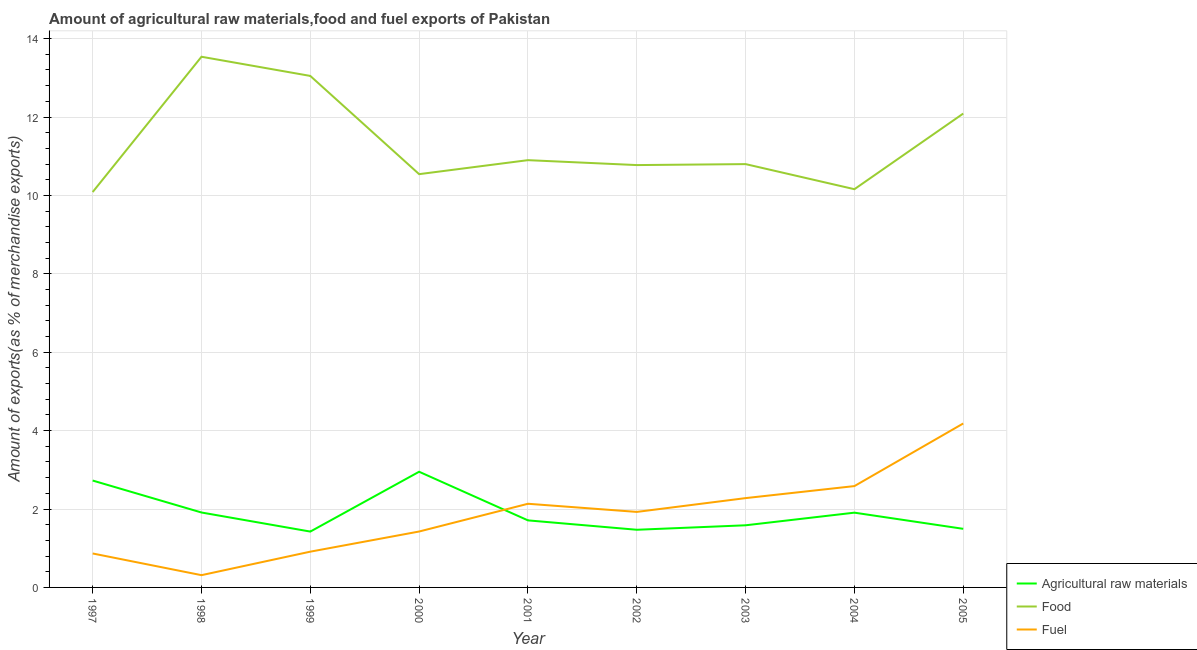Is the number of lines equal to the number of legend labels?
Provide a succinct answer. Yes. What is the percentage of raw materials exports in 2002?
Ensure brevity in your answer.  1.47. Across all years, what is the maximum percentage of fuel exports?
Your answer should be compact. 4.18. Across all years, what is the minimum percentage of food exports?
Offer a terse response. 10.09. In which year was the percentage of food exports maximum?
Your response must be concise. 1998. In which year was the percentage of raw materials exports minimum?
Offer a terse response. 1999. What is the total percentage of fuel exports in the graph?
Your answer should be very brief. 16.62. What is the difference between the percentage of fuel exports in 2004 and that in 2005?
Offer a very short reply. -1.6. What is the difference between the percentage of fuel exports in 1999 and the percentage of food exports in 2003?
Your answer should be compact. -9.89. What is the average percentage of fuel exports per year?
Offer a very short reply. 1.85. In the year 1999, what is the difference between the percentage of fuel exports and percentage of raw materials exports?
Offer a terse response. -0.51. What is the ratio of the percentage of fuel exports in 1997 to that in 2000?
Your answer should be very brief. 0.61. Is the difference between the percentage of food exports in 2002 and 2005 greater than the difference between the percentage of raw materials exports in 2002 and 2005?
Offer a terse response. No. What is the difference between the highest and the second highest percentage of raw materials exports?
Make the answer very short. 0.22. What is the difference between the highest and the lowest percentage of raw materials exports?
Give a very brief answer. 1.53. Is it the case that in every year, the sum of the percentage of raw materials exports and percentage of food exports is greater than the percentage of fuel exports?
Keep it short and to the point. Yes. Is the percentage of fuel exports strictly greater than the percentage of raw materials exports over the years?
Provide a succinct answer. No. How many lines are there?
Make the answer very short. 3. How many years are there in the graph?
Your response must be concise. 9. Where does the legend appear in the graph?
Offer a very short reply. Bottom right. What is the title of the graph?
Your answer should be very brief. Amount of agricultural raw materials,food and fuel exports of Pakistan. What is the label or title of the X-axis?
Keep it short and to the point. Year. What is the label or title of the Y-axis?
Keep it short and to the point. Amount of exports(as % of merchandise exports). What is the Amount of exports(as % of merchandise exports) of Agricultural raw materials in 1997?
Make the answer very short. 2.73. What is the Amount of exports(as % of merchandise exports) in Food in 1997?
Make the answer very short. 10.09. What is the Amount of exports(as % of merchandise exports) in Fuel in 1997?
Provide a short and direct response. 0.87. What is the Amount of exports(as % of merchandise exports) in Agricultural raw materials in 1998?
Offer a terse response. 1.91. What is the Amount of exports(as % of merchandise exports) of Food in 1998?
Offer a very short reply. 13.54. What is the Amount of exports(as % of merchandise exports) in Fuel in 1998?
Ensure brevity in your answer.  0.31. What is the Amount of exports(as % of merchandise exports) in Agricultural raw materials in 1999?
Offer a very short reply. 1.42. What is the Amount of exports(as % of merchandise exports) in Food in 1999?
Ensure brevity in your answer.  13.05. What is the Amount of exports(as % of merchandise exports) of Fuel in 1999?
Ensure brevity in your answer.  0.91. What is the Amount of exports(as % of merchandise exports) in Agricultural raw materials in 2000?
Offer a terse response. 2.95. What is the Amount of exports(as % of merchandise exports) of Food in 2000?
Provide a succinct answer. 10.54. What is the Amount of exports(as % of merchandise exports) of Fuel in 2000?
Offer a very short reply. 1.43. What is the Amount of exports(as % of merchandise exports) of Agricultural raw materials in 2001?
Your response must be concise. 1.71. What is the Amount of exports(as % of merchandise exports) of Food in 2001?
Make the answer very short. 10.9. What is the Amount of exports(as % of merchandise exports) in Fuel in 2001?
Your response must be concise. 2.13. What is the Amount of exports(as % of merchandise exports) in Agricultural raw materials in 2002?
Make the answer very short. 1.47. What is the Amount of exports(as % of merchandise exports) of Food in 2002?
Your answer should be compact. 10.77. What is the Amount of exports(as % of merchandise exports) in Fuel in 2002?
Make the answer very short. 1.93. What is the Amount of exports(as % of merchandise exports) of Agricultural raw materials in 2003?
Keep it short and to the point. 1.59. What is the Amount of exports(as % of merchandise exports) of Food in 2003?
Provide a short and direct response. 10.8. What is the Amount of exports(as % of merchandise exports) in Fuel in 2003?
Your answer should be compact. 2.28. What is the Amount of exports(as % of merchandise exports) of Agricultural raw materials in 2004?
Offer a terse response. 1.91. What is the Amount of exports(as % of merchandise exports) in Food in 2004?
Offer a very short reply. 10.16. What is the Amount of exports(as % of merchandise exports) of Fuel in 2004?
Ensure brevity in your answer.  2.59. What is the Amount of exports(as % of merchandise exports) in Agricultural raw materials in 2005?
Your answer should be compact. 1.49. What is the Amount of exports(as % of merchandise exports) in Food in 2005?
Provide a succinct answer. 12.09. What is the Amount of exports(as % of merchandise exports) in Fuel in 2005?
Offer a very short reply. 4.18. Across all years, what is the maximum Amount of exports(as % of merchandise exports) in Agricultural raw materials?
Your answer should be compact. 2.95. Across all years, what is the maximum Amount of exports(as % of merchandise exports) of Food?
Your answer should be very brief. 13.54. Across all years, what is the maximum Amount of exports(as % of merchandise exports) of Fuel?
Offer a very short reply. 4.18. Across all years, what is the minimum Amount of exports(as % of merchandise exports) of Agricultural raw materials?
Make the answer very short. 1.42. Across all years, what is the minimum Amount of exports(as % of merchandise exports) of Food?
Provide a short and direct response. 10.09. Across all years, what is the minimum Amount of exports(as % of merchandise exports) in Fuel?
Your response must be concise. 0.31. What is the total Amount of exports(as % of merchandise exports) of Agricultural raw materials in the graph?
Your answer should be very brief. 17.18. What is the total Amount of exports(as % of merchandise exports) of Food in the graph?
Give a very brief answer. 101.94. What is the total Amount of exports(as % of merchandise exports) in Fuel in the graph?
Your answer should be compact. 16.62. What is the difference between the Amount of exports(as % of merchandise exports) in Agricultural raw materials in 1997 and that in 1998?
Your response must be concise. 0.82. What is the difference between the Amount of exports(as % of merchandise exports) of Food in 1997 and that in 1998?
Your response must be concise. -3.45. What is the difference between the Amount of exports(as % of merchandise exports) of Fuel in 1997 and that in 1998?
Provide a succinct answer. 0.55. What is the difference between the Amount of exports(as % of merchandise exports) of Agricultural raw materials in 1997 and that in 1999?
Provide a succinct answer. 1.3. What is the difference between the Amount of exports(as % of merchandise exports) in Food in 1997 and that in 1999?
Keep it short and to the point. -2.96. What is the difference between the Amount of exports(as % of merchandise exports) of Fuel in 1997 and that in 1999?
Provide a short and direct response. -0.05. What is the difference between the Amount of exports(as % of merchandise exports) in Agricultural raw materials in 1997 and that in 2000?
Provide a short and direct response. -0.22. What is the difference between the Amount of exports(as % of merchandise exports) in Food in 1997 and that in 2000?
Provide a succinct answer. -0.46. What is the difference between the Amount of exports(as % of merchandise exports) of Fuel in 1997 and that in 2000?
Your answer should be compact. -0.56. What is the difference between the Amount of exports(as % of merchandise exports) of Agricultural raw materials in 1997 and that in 2001?
Provide a succinct answer. 1.02. What is the difference between the Amount of exports(as % of merchandise exports) in Food in 1997 and that in 2001?
Provide a short and direct response. -0.81. What is the difference between the Amount of exports(as % of merchandise exports) in Fuel in 1997 and that in 2001?
Give a very brief answer. -1.27. What is the difference between the Amount of exports(as % of merchandise exports) of Agricultural raw materials in 1997 and that in 2002?
Offer a very short reply. 1.26. What is the difference between the Amount of exports(as % of merchandise exports) in Food in 1997 and that in 2002?
Keep it short and to the point. -0.69. What is the difference between the Amount of exports(as % of merchandise exports) in Fuel in 1997 and that in 2002?
Your answer should be very brief. -1.06. What is the difference between the Amount of exports(as % of merchandise exports) of Agricultural raw materials in 1997 and that in 2003?
Give a very brief answer. 1.14. What is the difference between the Amount of exports(as % of merchandise exports) in Food in 1997 and that in 2003?
Give a very brief answer. -0.71. What is the difference between the Amount of exports(as % of merchandise exports) in Fuel in 1997 and that in 2003?
Offer a very short reply. -1.41. What is the difference between the Amount of exports(as % of merchandise exports) of Agricultural raw materials in 1997 and that in 2004?
Your answer should be compact. 0.82. What is the difference between the Amount of exports(as % of merchandise exports) of Food in 1997 and that in 2004?
Your answer should be very brief. -0.07. What is the difference between the Amount of exports(as % of merchandise exports) of Fuel in 1997 and that in 2004?
Make the answer very short. -1.72. What is the difference between the Amount of exports(as % of merchandise exports) of Agricultural raw materials in 1997 and that in 2005?
Give a very brief answer. 1.23. What is the difference between the Amount of exports(as % of merchandise exports) in Food in 1997 and that in 2005?
Offer a terse response. -2. What is the difference between the Amount of exports(as % of merchandise exports) of Fuel in 1997 and that in 2005?
Your answer should be compact. -3.32. What is the difference between the Amount of exports(as % of merchandise exports) of Agricultural raw materials in 1998 and that in 1999?
Your response must be concise. 0.49. What is the difference between the Amount of exports(as % of merchandise exports) of Food in 1998 and that in 1999?
Offer a terse response. 0.49. What is the difference between the Amount of exports(as % of merchandise exports) in Fuel in 1998 and that in 1999?
Your answer should be very brief. -0.6. What is the difference between the Amount of exports(as % of merchandise exports) of Agricultural raw materials in 1998 and that in 2000?
Your response must be concise. -1.04. What is the difference between the Amount of exports(as % of merchandise exports) of Food in 1998 and that in 2000?
Your response must be concise. 3. What is the difference between the Amount of exports(as % of merchandise exports) in Fuel in 1998 and that in 2000?
Your answer should be very brief. -1.11. What is the difference between the Amount of exports(as % of merchandise exports) of Agricultural raw materials in 1998 and that in 2001?
Offer a terse response. 0.2. What is the difference between the Amount of exports(as % of merchandise exports) in Food in 1998 and that in 2001?
Offer a terse response. 2.64. What is the difference between the Amount of exports(as % of merchandise exports) of Fuel in 1998 and that in 2001?
Ensure brevity in your answer.  -1.82. What is the difference between the Amount of exports(as % of merchandise exports) in Agricultural raw materials in 1998 and that in 2002?
Offer a terse response. 0.44. What is the difference between the Amount of exports(as % of merchandise exports) in Food in 1998 and that in 2002?
Make the answer very short. 2.76. What is the difference between the Amount of exports(as % of merchandise exports) of Fuel in 1998 and that in 2002?
Offer a terse response. -1.61. What is the difference between the Amount of exports(as % of merchandise exports) of Agricultural raw materials in 1998 and that in 2003?
Your answer should be very brief. 0.33. What is the difference between the Amount of exports(as % of merchandise exports) in Food in 1998 and that in 2003?
Give a very brief answer. 2.74. What is the difference between the Amount of exports(as % of merchandise exports) in Fuel in 1998 and that in 2003?
Your answer should be very brief. -1.97. What is the difference between the Amount of exports(as % of merchandise exports) of Agricultural raw materials in 1998 and that in 2004?
Ensure brevity in your answer.  0. What is the difference between the Amount of exports(as % of merchandise exports) in Food in 1998 and that in 2004?
Provide a short and direct response. 3.38. What is the difference between the Amount of exports(as % of merchandise exports) of Fuel in 1998 and that in 2004?
Your answer should be compact. -2.27. What is the difference between the Amount of exports(as % of merchandise exports) of Agricultural raw materials in 1998 and that in 2005?
Offer a very short reply. 0.42. What is the difference between the Amount of exports(as % of merchandise exports) of Food in 1998 and that in 2005?
Offer a terse response. 1.45. What is the difference between the Amount of exports(as % of merchandise exports) in Fuel in 1998 and that in 2005?
Your answer should be compact. -3.87. What is the difference between the Amount of exports(as % of merchandise exports) in Agricultural raw materials in 1999 and that in 2000?
Offer a terse response. -1.53. What is the difference between the Amount of exports(as % of merchandise exports) in Food in 1999 and that in 2000?
Provide a short and direct response. 2.51. What is the difference between the Amount of exports(as % of merchandise exports) in Fuel in 1999 and that in 2000?
Give a very brief answer. -0.51. What is the difference between the Amount of exports(as % of merchandise exports) in Agricultural raw materials in 1999 and that in 2001?
Your response must be concise. -0.29. What is the difference between the Amount of exports(as % of merchandise exports) in Food in 1999 and that in 2001?
Your answer should be compact. 2.15. What is the difference between the Amount of exports(as % of merchandise exports) in Fuel in 1999 and that in 2001?
Your answer should be very brief. -1.22. What is the difference between the Amount of exports(as % of merchandise exports) of Agricultural raw materials in 1999 and that in 2002?
Give a very brief answer. -0.05. What is the difference between the Amount of exports(as % of merchandise exports) of Food in 1999 and that in 2002?
Give a very brief answer. 2.27. What is the difference between the Amount of exports(as % of merchandise exports) in Fuel in 1999 and that in 2002?
Ensure brevity in your answer.  -1.01. What is the difference between the Amount of exports(as % of merchandise exports) in Agricultural raw materials in 1999 and that in 2003?
Your response must be concise. -0.16. What is the difference between the Amount of exports(as % of merchandise exports) in Food in 1999 and that in 2003?
Your answer should be compact. 2.25. What is the difference between the Amount of exports(as % of merchandise exports) in Fuel in 1999 and that in 2003?
Keep it short and to the point. -1.37. What is the difference between the Amount of exports(as % of merchandise exports) in Agricultural raw materials in 1999 and that in 2004?
Give a very brief answer. -0.48. What is the difference between the Amount of exports(as % of merchandise exports) in Food in 1999 and that in 2004?
Provide a succinct answer. 2.89. What is the difference between the Amount of exports(as % of merchandise exports) in Fuel in 1999 and that in 2004?
Ensure brevity in your answer.  -1.67. What is the difference between the Amount of exports(as % of merchandise exports) in Agricultural raw materials in 1999 and that in 2005?
Make the answer very short. -0.07. What is the difference between the Amount of exports(as % of merchandise exports) in Food in 1999 and that in 2005?
Keep it short and to the point. 0.96. What is the difference between the Amount of exports(as % of merchandise exports) in Fuel in 1999 and that in 2005?
Give a very brief answer. -3.27. What is the difference between the Amount of exports(as % of merchandise exports) in Agricultural raw materials in 2000 and that in 2001?
Your answer should be compact. 1.24. What is the difference between the Amount of exports(as % of merchandise exports) of Food in 2000 and that in 2001?
Your answer should be very brief. -0.36. What is the difference between the Amount of exports(as % of merchandise exports) of Fuel in 2000 and that in 2001?
Offer a terse response. -0.71. What is the difference between the Amount of exports(as % of merchandise exports) of Agricultural raw materials in 2000 and that in 2002?
Provide a short and direct response. 1.48. What is the difference between the Amount of exports(as % of merchandise exports) in Food in 2000 and that in 2002?
Your answer should be compact. -0.23. What is the difference between the Amount of exports(as % of merchandise exports) of Fuel in 2000 and that in 2002?
Provide a short and direct response. -0.5. What is the difference between the Amount of exports(as % of merchandise exports) in Agricultural raw materials in 2000 and that in 2003?
Give a very brief answer. 1.37. What is the difference between the Amount of exports(as % of merchandise exports) of Food in 2000 and that in 2003?
Offer a terse response. -0.26. What is the difference between the Amount of exports(as % of merchandise exports) in Fuel in 2000 and that in 2003?
Your answer should be very brief. -0.85. What is the difference between the Amount of exports(as % of merchandise exports) of Agricultural raw materials in 2000 and that in 2004?
Keep it short and to the point. 1.04. What is the difference between the Amount of exports(as % of merchandise exports) of Food in 2000 and that in 2004?
Give a very brief answer. 0.38. What is the difference between the Amount of exports(as % of merchandise exports) of Fuel in 2000 and that in 2004?
Your answer should be compact. -1.16. What is the difference between the Amount of exports(as % of merchandise exports) of Agricultural raw materials in 2000 and that in 2005?
Make the answer very short. 1.46. What is the difference between the Amount of exports(as % of merchandise exports) in Food in 2000 and that in 2005?
Offer a terse response. -1.55. What is the difference between the Amount of exports(as % of merchandise exports) of Fuel in 2000 and that in 2005?
Offer a terse response. -2.76. What is the difference between the Amount of exports(as % of merchandise exports) of Agricultural raw materials in 2001 and that in 2002?
Provide a short and direct response. 0.24. What is the difference between the Amount of exports(as % of merchandise exports) of Food in 2001 and that in 2002?
Keep it short and to the point. 0.13. What is the difference between the Amount of exports(as % of merchandise exports) of Fuel in 2001 and that in 2002?
Make the answer very short. 0.21. What is the difference between the Amount of exports(as % of merchandise exports) of Agricultural raw materials in 2001 and that in 2003?
Your answer should be very brief. 0.13. What is the difference between the Amount of exports(as % of merchandise exports) in Food in 2001 and that in 2003?
Offer a terse response. 0.1. What is the difference between the Amount of exports(as % of merchandise exports) in Fuel in 2001 and that in 2003?
Provide a succinct answer. -0.14. What is the difference between the Amount of exports(as % of merchandise exports) in Agricultural raw materials in 2001 and that in 2004?
Offer a very short reply. -0.2. What is the difference between the Amount of exports(as % of merchandise exports) of Food in 2001 and that in 2004?
Offer a terse response. 0.74. What is the difference between the Amount of exports(as % of merchandise exports) of Fuel in 2001 and that in 2004?
Provide a succinct answer. -0.45. What is the difference between the Amount of exports(as % of merchandise exports) of Agricultural raw materials in 2001 and that in 2005?
Ensure brevity in your answer.  0.22. What is the difference between the Amount of exports(as % of merchandise exports) of Food in 2001 and that in 2005?
Provide a succinct answer. -1.19. What is the difference between the Amount of exports(as % of merchandise exports) in Fuel in 2001 and that in 2005?
Keep it short and to the point. -2.05. What is the difference between the Amount of exports(as % of merchandise exports) of Agricultural raw materials in 2002 and that in 2003?
Your response must be concise. -0.11. What is the difference between the Amount of exports(as % of merchandise exports) in Food in 2002 and that in 2003?
Make the answer very short. -0.02. What is the difference between the Amount of exports(as % of merchandise exports) in Fuel in 2002 and that in 2003?
Your answer should be compact. -0.35. What is the difference between the Amount of exports(as % of merchandise exports) in Agricultural raw materials in 2002 and that in 2004?
Your response must be concise. -0.44. What is the difference between the Amount of exports(as % of merchandise exports) in Food in 2002 and that in 2004?
Give a very brief answer. 0.62. What is the difference between the Amount of exports(as % of merchandise exports) of Fuel in 2002 and that in 2004?
Your answer should be very brief. -0.66. What is the difference between the Amount of exports(as % of merchandise exports) in Agricultural raw materials in 2002 and that in 2005?
Your answer should be compact. -0.02. What is the difference between the Amount of exports(as % of merchandise exports) of Food in 2002 and that in 2005?
Provide a short and direct response. -1.31. What is the difference between the Amount of exports(as % of merchandise exports) in Fuel in 2002 and that in 2005?
Ensure brevity in your answer.  -2.26. What is the difference between the Amount of exports(as % of merchandise exports) in Agricultural raw materials in 2003 and that in 2004?
Keep it short and to the point. -0.32. What is the difference between the Amount of exports(as % of merchandise exports) in Food in 2003 and that in 2004?
Keep it short and to the point. 0.64. What is the difference between the Amount of exports(as % of merchandise exports) of Fuel in 2003 and that in 2004?
Your answer should be very brief. -0.31. What is the difference between the Amount of exports(as % of merchandise exports) in Agricultural raw materials in 2003 and that in 2005?
Ensure brevity in your answer.  0.09. What is the difference between the Amount of exports(as % of merchandise exports) of Food in 2003 and that in 2005?
Provide a short and direct response. -1.29. What is the difference between the Amount of exports(as % of merchandise exports) of Fuel in 2003 and that in 2005?
Ensure brevity in your answer.  -1.9. What is the difference between the Amount of exports(as % of merchandise exports) of Agricultural raw materials in 2004 and that in 2005?
Offer a terse response. 0.41. What is the difference between the Amount of exports(as % of merchandise exports) of Food in 2004 and that in 2005?
Provide a short and direct response. -1.93. What is the difference between the Amount of exports(as % of merchandise exports) in Fuel in 2004 and that in 2005?
Make the answer very short. -1.6. What is the difference between the Amount of exports(as % of merchandise exports) of Agricultural raw materials in 1997 and the Amount of exports(as % of merchandise exports) of Food in 1998?
Offer a very short reply. -10.81. What is the difference between the Amount of exports(as % of merchandise exports) of Agricultural raw materials in 1997 and the Amount of exports(as % of merchandise exports) of Fuel in 1998?
Ensure brevity in your answer.  2.41. What is the difference between the Amount of exports(as % of merchandise exports) of Food in 1997 and the Amount of exports(as % of merchandise exports) of Fuel in 1998?
Make the answer very short. 9.77. What is the difference between the Amount of exports(as % of merchandise exports) of Agricultural raw materials in 1997 and the Amount of exports(as % of merchandise exports) of Food in 1999?
Keep it short and to the point. -10.32. What is the difference between the Amount of exports(as % of merchandise exports) of Agricultural raw materials in 1997 and the Amount of exports(as % of merchandise exports) of Fuel in 1999?
Make the answer very short. 1.81. What is the difference between the Amount of exports(as % of merchandise exports) of Food in 1997 and the Amount of exports(as % of merchandise exports) of Fuel in 1999?
Make the answer very short. 9.17. What is the difference between the Amount of exports(as % of merchandise exports) in Agricultural raw materials in 1997 and the Amount of exports(as % of merchandise exports) in Food in 2000?
Provide a succinct answer. -7.82. What is the difference between the Amount of exports(as % of merchandise exports) in Agricultural raw materials in 1997 and the Amount of exports(as % of merchandise exports) in Fuel in 2000?
Give a very brief answer. 1.3. What is the difference between the Amount of exports(as % of merchandise exports) of Food in 1997 and the Amount of exports(as % of merchandise exports) of Fuel in 2000?
Offer a very short reply. 8.66. What is the difference between the Amount of exports(as % of merchandise exports) in Agricultural raw materials in 1997 and the Amount of exports(as % of merchandise exports) in Food in 2001?
Give a very brief answer. -8.17. What is the difference between the Amount of exports(as % of merchandise exports) of Agricultural raw materials in 1997 and the Amount of exports(as % of merchandise exports) of Fuel in 2001?
Keep it short and to the point. 0.59. What is the difference between the Amount of exports(as % of merchandise exports) of Food in 1997 and the Amount of exports(as % of merchandise exports) of Fuel in 2001?
Provide a short and direct response. 7.95. What is the difference between the Amount of exports(as % of merchandise exports) of Agricultural raw materials in 1997 and the Amount of exports(as % of merchandise exports) of Food in 2002?
Offer a very short reply. -8.05. What is the difference between the Amount of exports(as % of merchandise exports) of Agricultural raw materials in 1997 and the Amount of exports(as % of merchandise exports) of Fuel in 2002?
Ensure brevity in your answer.  0.8. What is the difference between the Amount of exports(as % of merchandise exports) in Food in 1997 and the Amount of exports(as % of merchandise exports) in Fuel in 2002?
Offer a terse response. 8.16. What is the difference between the Amount of exports(as % of merchandise exports) in Agricultural raw materials in 1997 and the Amount of exports(as % of merchandise exports) in Food in 2003?
Your response must be concise. -8.07. What is the difference between the Amount of exports(as % of merchandise exports) in Agricultural raw materials in 1997 and the Amount of exports(as % of merchandise exports) in Fuel in 2003?
Your response must be concise. 0.45. What is the difference between the Amount of exports(as % of merchandise exports) of Food in 1997 and the Amount of exports(as % of merchandise exports) of Fuel in 2003?
Keep it short and to the point. 7.81. What is the difference between the Amount of exports(as % of merchandise exports) of Agricultural raw materials in 1997 and the Amount of exports(as % of merchandise exports) of Food in 2004?
Offer a very short reply. -7.43. What is the difference between the Amount of exports(as % of merchandise exports) in Agricultural raw materials in 1997 and the Amount of exports(as % of merchandise exports) in Fuel in 2004?
Provide a short and direct response. 0.14. What is the difference between the Amount of exports(as % of merchandise exports) of Food in 1997 and the Amount of exports(as % of merchandise exports) of Fuel in 2004?
Your answer should be very brief. 7.5. What is the difference between the Amount of exports(as % of merchandise exports) in Agricultural raw materials in 1997 and the Amount of exports(as % of merchandise exports) in Food in 2005?
Offer a terse response. -9.36. What is the difference between the Amount of exports(as % of merchandise exports) of Agricultural raw materials in 1997 and the Amount of exports(as % of merchandise exports) of Fuel in 2005?
Provide a short and direct response. -1.46. What is the difference between the Amount of exports(as % of merchandise exports) in Food in 1997 and the Amount of exports(as % of merchandise exports) in Fuel in 2005?
Keep it short and to the point. 5.9. What is the difference between the Amount of exports(as % of merchandise exports) in Agricultural raw materials in 1998 and the Amount of exports(as % of merchandise exports) in Food in 1999?
Your response must be concise. -11.14. What is the difference between the Amount of exports(as % of merchandise exports) of Agricultural raw materials in 1998 and the Amount of exports(as % of merchandise exports) of Fuel in 1999?
Provide a short and direct response. 1. What is the difference between the Amount of exports(as % of merchandise exports) of Food in 1998 and the Amount of exports(as % of merchandise exports) of Fuel in 1999?
Keep it short and to the point. 12.63. What is the difference between the Amount of exports(as % of merchandise exports) in Agricultural raw materials in 1998 and the Amount of exports(as % of merchandise exports) in Food in 2000?
Your answer should be very brief. -8.63. What is the difference between the Amount of exports(as % of merchandise exports) in Agricultural raw materials in 1998 and the Amount of exports(as % of merchandise exports) in Fuel in 2000?
Keep it short and to the point. 0.49. What is the difference between the Amount of exports(as % of merchandise exports) of Food in 1998 and the Amount of exports(as % of merchandise exports) of Fuel in 2000?
Keep it short and to the point. 12.11. What is the difference between the Amount of exports(as % of merchandise exports) of Agricultural raw materials in 1998 and the Amount of exports(as % of merchandise exports) of Food in 2001?
Offer a terse response. -8.99. What is the difference between the Amount of exports(as % of merchandise exports) in Agricultural raw materials in 1998 and the Amount of exports(as % of merchandise exports) in Fuel in 2001?
Offer a very short reply. -0.22. What is the difference between the Amount of exports(as % of merchandise exports) in Food in 1998 and the Amount of exports(as % of merchandise exports) in Fuel in 2001?
Give a very brief answer. 11.4. What is the difference between the Amount of exports(as % of merchandise exports) of Agricultural raw materials in 1998 and the Amount of exports(as % of merchandise exports) of Food in 2002?
Your response must be concise. -8.86. What is the difference between the Amount of exports(as % of merchandise exports) in Agricultural raw materials in 1998 and the Amount of exports(as % of merchandise exports) in Fuel in 2002?
Your answer should be very brief. -0.01. What is the difference between the Amount of exports(as % of merchandise exports) in Food in 1998 and the Amount of exports(as % of merchandise exports) in Fuel in 2002?
Provide a succinct answer. 11.61. What is the difference between the Amount of exports(as % of merchandise exports) in Agricultural raw materials in 1998 and the Amount of exports(as % of merchandise exports) in Food in 2003?
Your response must be concise. -8.89. What is the difference between the Amount of exports(as % of merchandise exports) in Agricultural raw materials in 1998 and the Amount of exports(as % of merchandise exports) in Fuel in 2003?
Offer a very short reply. -0.37. What is the difference between the Amount of exports(as % of merchandise exports) in Food in 1998 and the Amount of exports(as % of merchandise exports) in Fuel in 2003?
Give a very brief answer. 11.26. What is the difference between the Amount of exports(as % of merchandise exports) in Agricultural raw materials in 1998 and the Amount of exports(as % of merchandise exports) in Food in 2004?
Make the answer very short. -8.25. What is the difference between the Amount of exports(as % of merchandise exports) in Agricultural raw materials in 1998 and the Amount of exports(as % of merchandise exports) in Fuel in 2004?
Offer a terse response. -0.67. What is the difference between the Amount of exports(as % of merchandise exports) in Food in 1998 and the Amount of exports(as % of merchandise exports) in Fuel in 2004?
Provide a short and direct response. 10.95. What is the difference between the Amount of exports(as % of merchandise exports) of Agricultural raw materials in 1998 and the Amount of exports(as % of merchandise exports) of Food in 2005?
Ensure brevity in your answer.  -10.18. What is the difference between the Amount of exports(as % of merchandise exports) of Agricultural raw materials in 1998 and the Amount of exports(as % of merchandise exports) of Fuel in 2005?
Your answer should be compact. -2.27. What is the difference between the Amount of exports(as % of merchandise exports) in Food in 1998 and the Amount of exports(as % of merchandise exports) in Fuel in 2005?
Give a very brief answer. 9.36. What is the difference between the Amount of exports(as % of merchandise exports) of Agricultural raw materials in 1999 and the Amount of exports(as % of merchandise exports) of Food in 2000?
Offer a terse response. -9.12. What is the difference between the Amount of exports(as % of merchandise exports) in Agricultural raw materials in 1999 and the Amount of exports(as % of merchandise exports) in Fuel in 2000?
Your answer should be very brief. -0. What is the difference between the Amount of exports(as % of merchandise exports) in Food in 1999 and the Amount of exports(as % of merchandise exports) in Fuel in 2000?
Your answer should be very brief. 11.62. What is the difference between the Amount of exports(as % of merchandise exports) of Agricultural raw materials in 1999 and the Amount of exports(as % of merchandise exports) of Food in 2001?
Your response must be concise. -9.48. What is the difference between the Amount of exports(as % of merchandise exports) in Agricultural raw materials in 1999 and the Amount of exports(as % of merchandise exports) in Fuel in 2001?
Ensure brevity in your answer.  -0.71. What is the difference between the Amount of exports(as % of merchandise exports) of Food in 1999 and the Amount of exports(as % of merchandise exports) of Fuel in 2001?
Provide a succinct answer. 10.91. What is the difference between the Amount of exports(as % of merchandise exports) in Agricultural raw materials in 1999 and the Amount of exports(as % of merchandise exports) in Food in 2002?
Your answer should be compact. -9.35. What is the difference between the Amount of exports(as % of merchandise exports) in Agricultural raw materials in 1999 and the Amount of exports(as % of merchandise exports) in Fuel in 2002?
Offer a terse response. -0.5. What is the difference between the Amount of exports(as % of merchandise exports) in Food in 1999 and the Amount of exports(as % of merchandise exports) in Fuel in 2002?
Keep it short and to the point. 11.12. What is the difference between the Amount of exports(as % of merchandise exports) in Agricultural raw materials in 1999 and the Amount of exports(as % of merchandise exports) in Food in 2003?
Provide a succinct answer. -9.37. What is the difference between the Amount of exports(as % of merchandise exports) in Agricultural raw materials in 1999 and the Amount of exports(as % of merchandise exports) in Fuel in 2003?
Keep it short and to the point. -0.85. What is the difference between the Amount of exports(as % of merchandise exports) of Food in 1999 and the Amount of exports(as % of merchandise exports) of Fuel in 2003?
Make the answer very short. 10.77. What is the difference between the Amount of exports(as % of merchandise exports) in Agricultural raw materials in 1999 and the Amount of exports(as % of merchandise exports) in Food in 2004?
Your answer should be very brief. -8.73. What is the difference between the Amount of exports(as % of merchandise exports) in Agricultural raw materials in 1999 and the Amount of exports(as % of merchandise exports) in Fuel in 2004?
Make the answer very short. -1.16. What is the difference between the Amount of exports(as % of merchandise exports) in Food in 1999 and the Amount of exports(as % of merchandise exports) in Fuel in 2004?
Provide a short and direct response. 10.46. What is the difference between the Amount of exports(as % of merchandise exports) of Agricultural raw materials in 1999 and the Amount of exports(as % of merchandise exports) of Food in 2005?
Ensure brevity in your answer.  -10.66. What is the difference between the Amount of exports(as % of merchandise exports) of Agricultural raw materials in 1999 and the Amount of exports(as % of merchandise exports) of Fuel in 2005?
Ensure brevity in your answer.  -2.76. What is the difference between the Amount of exports(as % of merchandise exports) in Food in 1999 and the Amount of exports(as % of merchandise exports) in Fuel in 2005?
Your answer should be compact. 8.87. What is the difference between the Amount of exports(as % of merchandise exports) of Agricultural raw materials in 2000 and the Amount of exports(as % of merchandise exports) of Food in 2001?
Provide a succinct answer. -7.95. What is the difference between the Amount of exports(as % of merchandise exports) in Agricultural raw materials in 2000 and the Amount of exports(as % of merchandise exports) in Fuel in 2001?
Keep it short and to the point. 0.82. What is the difference between the Amount of exports(as % of merchandise exports) in Food in 2000 and the Amount of exports(as % of merchandise exports) in Fuel in 2001?
Keep it short and to the point. 8.41. What is the difference between the Amount of exports(as % of merchandise exports) of Agricultural raw materials in 2000 and the Amount of exports(as % of merchandise exports) of Food in 2002?
Keep it short and to the point. -7.82. What is the difference between the Amount of exports(as % of merchandise exports) in Agricultural raw materials in 2000 and the Amount of exports(as % of merchandise exports) in Fuel in 2002?
Keep it short and to the point. 1.02. What is the difference between the Amount of exports(as % of merchandise exports) of Food in 2000 and the Amount of exports(as % of merchandise exports) of Fuel in 2002?
Offer a terse response. 8.62. What is the difference between the Amount of exports(as % of merchandise exports) of Agricultural raw materials in 2000 and the Amount of exports(as % of merchandise exports) of Food in 2003?
Your answer should be compact. -7.85. What is the difference between the Amount of exports(as % of merchandise exports) of Agricultural raw materials in 2000 and the Amount of exports(as % of merchandise exports) of Fuel in 2003?
Provide a succinct answer. 0.67. What is the difference between the Amount of exports(as % of merchandise exports) in Food in 2000 and the Amount of exports(as % of merchandise exports) in Fuel in 2003?
Your answer should be very brief. 8.26. What is the difference between the Amount of exports(as % of merchandise exports) of Agricultural raw materials in 2000 and the Amount of exports(as % of merchandise exports) of Food in 2004?
Provide a short and direct response. -7.21. What is the difference between the Amount of exports(as % of merchandise exports) of Agricultural raw materials in 2000 and the Amount of exports(as % of merchandise exports) of Fuel in 2004?
Give a very brief answer. 0.37. What is the difference between the Amount of exports(as % of merchandise exports) in Food in 2000 and the Amount of exports(as % of merchandise exports) in Fuel in 2004?
Offer a very short reply. 7.96. What is the difference between the Amount of exports(as % of merchandise exports) of Agricultural raw materials in 2000 and the Amount of exports(as % of merchandise exports) of Food in 2005?
Give a very brief answer. -9.14. What is the difference between the Amount of exports(as % of merchandise exports) of Agricultural raw materials in 2000 and the Amount of exports(as % of merchandise exports) of Fuel in 2005?
Your answer should be very brief. -1.23. What is the difference between the Amount of exports(as % of merchandise exports) in Food in 2000 and the Amount of exports(as % of merchandise exports) in Fuel in 2005?
Your answer should be compact. 6.36. What is the difference between the Amount of exports(as % of merchandise exports) in Agricultural raw materials in 2001 and the Amount of exports(as % of merchandise exports) in Food in 2002?
Offer a terse response. -9.06. What is the difference between the Amount of exports(as % of merchandise exports) of Agricultural raw materials in 2001 and the Amount of exports(as % of merchandise exports) of Fuel in 2002?
Provide a short and direct response. -0.22. What is the difference between the Amount of exports(as % of merchandise exports) of Food in 2001 and the Amount of exports(as % of merchandise exports) of Fuel in 2002?
Give a very brief answer. 8.97. What is the difference between the Amount of exports(as % of merchandise exports) in Agricultural raw materials in 2001 and the Amount of exports(as % of merchandise exports) in Food in 2003?
Your answer should be compact. -9.09. What is the difference between the Amount of exports(as % of merchandise exports) in Agricultural raw materials in 2001 and the Amount of exports(as % of merchandise exports) in Fuel in 2003?
Ensure brevity in your answer.  -0.57. What is the difference between the Amount of exports(as % of merchandise exports) of Food in 2001 and the Amount of exports(as % of merchandise exports) of Fuel in 2003?
Give a very brief answer. 8.62. What is the difference between the Amount of exports(as % of merchandise exports) of Agricultural raw materials in 2001 and the Amount of exports(as % of merchandise exports) of Food in 2004?
Provide a short and direct response. -8.45. What is the difference between the Amount of exports(as % of merchandise exports) in Agricultural raw materials in 2001 and the Amount of exports(as % of merchandise exports) in Fuel in 2004?
Keep it short and to the point. -0.87. What is the difference between the Amount of exports(as % of merchandise exports) of Food in 2001 and the Amount of exports(as % of merchandise exports) of Fuel in 2004?
Provide a succinct answer. 8.31. What is the difference between the Amount of exports(as % of merchandise exports) in Agricultural raw materials in 2001 and the Amount of exports(as % of merchandise exports) in Food in 2005?
Your answer should be compact. -10.38. What is the difference between the Amount of exports(as % of merchandise exports) of Agricultural raw materials in 2001 and the Amount of exports(as % of merchandise exports) of Fuel in 2005?
Offer a very short reply. -2.47. What is the difference between the Amount of exports(as % of merchandise exports) in Food in 2001 and the Amount of exports(as % of merchandise exports) in Fuel in 2005?
Make the answer very short. 6.72. What is the difference between the Amount of exports(as % of merchandise exports) of Agricultural raw materials in 2002 and the Amount of exports(as % of merchandise exports) of Food in 2003?
Provide a short and direct response. -9.33. What is the difference between the Amount of exports(as % of merchandise exports) in Agricultural raw materials in 2002 and the Amount of exports(as % of merchandise exports) in Fuel in 2003?
Make the answer very short. -0.81. What is the difference between the Amount of exports(as % of merchandise exports) in Food in 2002 and the Amount of exports(as % of merchandise exports) in Fuel in 2003?
Your answer should be compact. 8.5. What is the difference between the Amount of exports(as % of merchandise exports) in Agricultural raw materials in 2002 and the Amount of exports(as % of merchandise exports) in Food in 2004?
Offer a terse response. -8.69. What is the difference between the Amount of exports(as % of merchandise exports) in Agricultural raw materials in 2002 and the Amount of exports(as % of merchandise exports) in Fuel in 2004?
Give a very brief answer. -1.11. What is the difference between the Amount of exports(as % of merchandise exports) in Food in 2002 and the Amount of exports(as % of merchandise exports) in Fuel in 2004?
Offer a very short reply. 8.19. What is the difference between the Amount of exports(as % of merchandise exports) of Agricultural raw materials in 2002 and the Amount of exports(as % of merchandise exports) of Food in 2005?
Provide a succinct answer. -10.62. What is the difference between the Amount of exports(as % of merchandise exports) of Agricultural raw materials in 2002 and the Amount of exports(as % of merchandise exports) of Fuel in 2005?
Give a very brief answer. -2.71. What is the difference between the Amount of exports(as % of merchandise exports) in Food in 2002 and the Amount of exports(as % of merchandise exports) in Fuel in 2005?
Offer a very short reply. 6.59. What is the difference between the Amount of exports(as % of merchandise exports) in Agricultural raw materials in 2003 and the Amount of exports(as % of merchandise exports) in Food in 2004?
Your response must be concise. -8.57. What is the difference between the Amount of exports(as % of merchandise exports) in Agricultural raw materials in 2003 and the Amount of exports(as % of merchandise exports) in Fuel in 2004?
Your answer should be compact. -1. What is the difference between the Amount of exports(as % of merchandise exports) of Food in 2003 and the Amount of exports(as % of merchandise exports) of Fuel in 2004?
Make the answer very short. 8.21. What is the difference between the Amount of exports(as % of merchandise exports) of Agricultural raw materials in 2003 and the Amount of exports(as % of merchandise exports) of Food in 2005?
Give a very brief answer. -10.5. What is the difference between the Amount of exports(as % of merchandise exports) in Agricultural raw materials in 2003 and the Amount of exports(as % of merchandise exports) in Fuel in 2005?
Your response must be concise. -2.6. What is the difference between the Amount of exports(as % of merchandise exports) of Food in 2003 and the Amount of exports(as % of merchandise exports) of Fuel in 2005?
Your answer should be very brief. 6.62. What is the difference between the Amount of exports(as % of merchandise exports) in Agricultural raw materials in 2004 and the Amount of exports(as % of merchandise exports) in Food in 2005?
Make the answer very short. -10.18. What is the difference between the Amount of exports(as % of merchandise exports) in Agricultural raw materials in 2004 and the Amount of exports(as % of merchandise exports) in Fuel in 2005?
Ensure brevity in your answer.  -2.27. What is the difference between the Amount of exports(as % of merchandise exports) of Food in 2004 and the Amount of exports(as % of merchandise exports) of Fuel in 2005?
Make the answer very short. 5.98. What is the average Amount of exports(as % of merchandise exports) of Agricultural raw materials per year?
Your answer should be very brief. 1.91. What is the average Amount of exports(as % of merchandise exports) in Food per year?
Offer a very short reply. 11.33. What is the average Amount of exports(as % of merchandise exports) of Fuel per year?
Provide a succinct answer. 1.85. In the year 1997, what is the difference between the Amount of exports(as % of merchandise exports) of Agricultural raw materials and Amount of exports(as % of merchandise exports) of Food?
Give a very brief answer. -7.36. In the year 1997, what is the difference between the Amount of exports(as % of merchandise exports) in Agricultural raw materials and Amount of exports(as % of merchandise exports) in Fuel?
Make the answer very short. 1.86. In the year 1997, what is the difference between the Amount of exports(as % of merchandise exports) in Food and Amount of exports(as % of merchandise exports) in Fuel?
Your answer should be very brief. 9.22. In the year 1998, what is the difference between the Amount of exports(as % of merchandise exports) of Agricultural raw materials and Amount of exports(as % of merchandise exports) of Food?
Offer a very short reply. -11.63. In the year 1998, what is the difference between the Amount of exports(as % of merchandise exports) of Agricultural raw materials and Amount of exports(as % of merchandise exports) of Fuel?
Keep it short and to the point. 1.6. In the year 1998, what is the difference between the Amount of exports(as % of merchandise exports) in Food and Amount of exports(as % of merchandise exports) in Fuel?
Make the answer very short. 13.22. In the year 1999, what is the difference between the Amount of exports(as % of merchandise exports) in Agricultural raw materials and Amount of exports(as % of merchandise exports) in Food?
Your answer should be very brief. -11.62. In the year 1999, what is the difference between the Amount of exports(as % of merchandise exports) of Agricultural raw materials and Amount of exports(as % of merchandise exports) of Fuel?
Give a very brief answer. 0.51. In the year 1999, what is the difference between the Amount of exports(as % of merchandise exports) of Food and Amount of exports(as % of merchandise exports) of Fuel?
Your answer should be compact. 12.14. In the year 2000, what is the difference between the Amount of exports(as % of merchandise exports) of Agricultural raw materials and Amount of exports(as % of merchandise exports) of Food?
Make the answer very short. -7.59. In the year 2000, what is the difference between the Amount of exports(as % of merchandise exports) in Agricultural raw materials and Amount of exports(as % of merchandise exports) in Fuel?
Your response must be concise. 1.52. In the year 2000, what is the difference between the Amount of exports(as % of merchandise exports) in Food and Amount of exports(as % of merchandise exports) in Fuel?
Offer a terse response. 9.12. In the year 2001, what is the difference between the Amount of exports(as % of merchandise exports) in Agricultural raw materials and Amount of exports(as % of merchandise exports) in Food?
Provide a succinct answer. -9.19. In the year 2001, what is the difference between the Amount of exports(as % of merchandise exports) of Agricultural raw materials and Amount of exports(as % of merchandise exports) of Fuel?
Provide a succinct answer. -0.42. In the year 2001, what is the difference between the Amount of exports(as % of merchandise exports) of Food and Amount of exports(as % of merchandise exports) of Fuel?
Keep it short and to the point. 8.77. In the year 2002, what is the difference between the Amount of exports(as % of merchandise exports) in Agricultural raw materials and Amount of exports(as % of merchandise exports) in Food?
Offer a very short reply. -9.3. In the year 2002, what is the difference between the Amount of exports(as % of merchandise exports) in Agricultural raw materials and Amount of exports(as % of merchandise exports) in Fuel?
Offer a very short reply. -0.46. In the year 2002, what is the difference between the Amount of exports(as % of merchandise exports) in Food and Amount of exports(as % of merchandise exports) in Fuel?
Provide a succinct answer. 8.85. In the year 2003, what is the difference between the Amount of exports(as % of merchandise exports) of Agricultural raw materials and Amount of exports(as % of merchandise exports) of Food?
Ensure brevity in your answer.  -9.21. In the year 2003, what is the difference between the Amount of exports(as % of merchandise exports) of Agricultural raw materials and Amount of exports(as % of merchandise exports) of Fuel?
Your answer should be very brief. -0.69. In the year 2003, what is the difference between the Amount of exports(as % of merchandise exports) in Food and Amount of exports(as % of merchandise exports) in Fuel?
Provide a short and direct response. 8.52. In the year 2004, what is the difference between the Amount of exports(as % of merchandise exports) of Agricultural raw materials and Amount of exports(as % of merchandise exports) of Food?
Provide a short and direct response. -8.25. In the year 2004, what is the difference between the Amount of exports(as % of merchandise exports) of Agricultural raw materials and Amount of exports(as % of merchandise exports) of Fuel?
Ensure brevity in your answer.  -0.68. In the year 2004, what is the difference between the Amount of exports(as % of merchandise exports) of Food and Amount of exports(as % of merchandise exports) of Fuel?
Your answer should be compact. 7.57. In the year 2005, what is the difference between the Amount of exports(as % of merchandise exports) of Agricultural raw materials and Amount of exports(as % of merchandise exports) of Food?
Make the answer very short. -10.59. In the year 2005, what is the difference between the Amount of exports(as % of merchandise exports) of Agricultural raw materials and Amount of exports(as % of merchandise exports) of Fuel?
Your response must be concise. -2.69. In the year 2005, what is the difference between the Amount of exports(as % of merchandise exports) of Food and Amount of exports(as % of merchandise exports) of Fuel?
Keep it short and to the point. 7.91. What is the ratio of the Amount of exports(as % of merchandise exports) of Agricultural raw materials in 1997 to that in 1998?
Your answer should be very brief. 1.43. What is the ratio of the Amount of exports(as % of merchandise exports) of Food in 1997 to that in 1998?
Your answer should be very brief. 0.74. What is the ratio of the Amount of exports(as % of merchandise exports) in Fuel in 1997 to that in 1998?
Ensure brevity in your answer.  2.77. What is the ratio of the Amount of exports(as % of merchandise exports) in Agricultural raw materials in 1997 to that in 1999?
Provide a succinct answer. 1.91. What is the ratio of the Amount of exports(as % of merchandise exports) of Food in 1997 to that in 1999?
Keep it short and to the point. 0.77. What is the ratio of the Amount of exports(as % of merchandise exports) of Fuel in 1997 to that in 1999?
Give a very brief answer. 0.95. What is the ratio of the Amount of exports(as % of merchandise exports) of Agricultural raw materials in 1997 to that in 2000?
Keep it short and to the point. 0.92. What is the ratio of the Amount of exports(as % of merchandise exports) of Food in 1997 to that in 2000?
Give a very brief answer. 0.96. What is the ratio of the Amount of exports(as % of merchandise exports) of Fuel in 1997 to that in 2000?
Offer a very short reply. 0.61. What is the ratio of the Amount of exports(as % of merchandise exports) in Agricultural raw materials in 1997 to that in 2001?
Your response must be concise. 1.59. What is the ratio of the Amount of exports(as % of merchandise exports) of Food in 1997 to that in 2001?
Offer a very short reply. 0.93. What is the ratio of the Amount of exports(as % of merchandise exports) in Fuel in 1997 to that in 2001?
Offer a terse response. 0.41. What is the ratio of the Amount of exports(as % of merchandise exports) in Agricultural raw materials in 1997 to that in 2002?
Ensure brevity in your answer.  1.85. What is the ratio of the Amount of exports(as % of merchandise exports) in Food in 1997 to that in 2002?
Offer a very short reply. 0.94. What is the ratio of the Amount of exports(as % of merchandise exports) in Fuel in 1997 to that in 2002?
Your response must be concise. 0.45. What is the ratio of the Amount of exports(as % of merchandise exports) in Agricultural raw materials in 1997 to that in 2003?
Your answer should be compact. 1.72. What is the ratio of the Amount of exports(as % of merchandise exports) of Food in 1997 to that in 2003?
Make the answer very short. 0.93. What is the ratio of the Amount of exports(as % of merchandise exports) of Fuel in 1997 to that in 2003?
Ensure brevity in your answer.  0.38. What is the ratio of the Amount of exports(as % of merchandise exports) in Agricultural raw materials in 1997 to that in 2004?
Provide a short and direct response. 1.43. What is the ratio of the Amount of exports(as % of merchandise exports) in Fuel in 1997 to that in 2004?
Your answer should be compact. 0.34. What is the ratio of the Amount of exports(as % of merchandise exports) of Agricultural raw materials in 1997 to that in 2005?
Provide a succinct answer. 1.82. What is the ratio of the Amount of exports(as % of merchandise exports) in Food in 1997 to that in 2005?
Your response must be concise. 0.83. What is the ratio of the Amount of exports(as % of merchandise exports) in Fuel in 1997 to that in 2005?
Your answer should be compact. 0.21. What is the ratio of the Amount of exports(as % of merchandise exports) in Agricultural raw materials in 1998 to that in 1999?
Provide a short and direct response. 1.34. What is the ratio of the Amount of exports(as % of merchandise exports) of Food in 1998 to that in 1999?
Give a very brief answer. 1.04. What is the ratio of the Amount of exports(as % of merchandise exports) in Fuel in 1998 to that in 1999?
Your answer should be compact. 0.34. What is the ratio of the Amount of exports(as % of merchandise exports) of Agricultural raw materials in 1998 to that in 2000?
Keep it short and to the point. 0.65. What is the ratio of the Amount of exports(as % of merchandise exports) of Food in 1998 to that in 2000?
Your answer should be compact. 1.28. What is the ratio of the Amount of exports(as % of merchandise exports) of Fuel in 1998 to that in 2000?
Make the answer very short. 0.22. What is the ratio of the Amount of exports(as % of merchandise exports) in Agricultural raw materials in 1998 to that in 2001?
Give a very brief answer. 1.12. What is the ratio of the Amount of exports(as % of merchandise exports) of Food in 1998 to that in 2001?
Provide a succinct answer. 1.24. What is the ratio of the Amount of exports(as % of merchandise exports) in Fuel in 1998 to that in 2001?
Your answer should be compact. 0.15. What is the ratio of the Amount of exports(as % of merchandise exports) in Agricultural raw materials in 1998 to that in 2002?
Keep it short and to the point. 1.3. What is the ratio of the Amount of exports(as % of merchandise exports) of Food in 1998 to that in 2002?
Offer a very short reply. 1.26. What is the ratio of the Amount of exports(as % of merchandise exports) of Fuel in 1998 to that in 2002?
Keep it short and to the point. 0.16. What is the ratio of the Amount of exports(as % of merchandise exports) of Agricultural raw materials in 1998 to that in 2003?
Make the answer very short. 1.21. What is the ratio of the Amount of exports(as % of merchandise exports) of Food in 1998 to that in 2003?
Your answer should be compact. 1.25. What is the ratio of the Amount of exports(as % of merchandise exports) of Fuel in 1998 to that in 2003?
Keep it short and to the point. 0.14. What is the ratio of the Amount of exports(as % of merchandise exports) of Food in 1998 to that in 2004?
Provide a succinct answer. 1.33. What is the ratio of the Amount of exports(as % of merchandise exports) of Fuel in 1998 to that in 2004?
Make the answer very short. 0.12. What is the ratio of the Amount of exports(as % of merchandise exports) in Agricultural raw materials in 1998 to that in 2005?
Keep it short and to the point. 1.28. What is the ratio of the Amount of exports(as % of merchandise exports) of Food in 1998 to that in 2005?
Provide a short and direct response. 1.12. What is the ratio of the Amount of exports(as % of merchandise exports) of Fuel in 1998 to that in 2005?
Ensure brevity in your answer.  0.07. What is the ratio of the Amount of exports(as % of merchandise exports) of Agricultural raw materials in 1999 to that in 2000?
Ensure brevity in your answer.  0.48. What is the ratio of the Amount of exports(as % of merchandise exports) of Food in 1999 to that in 2000?
Provide a short and direct response. 1.24. What is the ratio of the Amount of exports(as % of merchandise exports) in Fuel in 1999 to that in 2000?
Provide a succinct answer. 0.64. What is the ratio of the Amount of exports(as % of merchandise exports) in Agricultural raw materials in 1999 to that in 2001?
Ensure brevity in your answer.  0.83. What is the ratio of the Amount of exports(as % of merchandise exports) of Food in 1999 to that in 2001?
Offer a terse response. 1.2. What is the ratio of the Amount of exports(as % of merchandise exports) in Fuel in 1999 to that in 2001?
Your response must be concise. 0.43. What is the ratio of the Amount of exports(as % of merchandise exports) of Agricultural raw materials in 1999 to that in 2002?
Ensure brevity in your answer.  0.97. What is the ratio of the Amount of exports(as % of merchandise exports) in Food in 1999 to that in 2002?
Make the answer very short. 1.21. What is the ratio of the Amount of exports(as % of merchandise exports) in Fuel in 1999 to that in 2002?
Offer a terse response. 0.47. What is the ratio of the Amount of exports(as % of merchandise exports) of Agricultural raw materials in 1999 to that in 2003?
Provide a short and direct response. 0.9. What is the ratio of the Amount of exports(as % of merchandise exports) in Food in 1999 to that in 2003?
Offer a terse response. 1.21. What is the ratio of the Amount of exports(as % of merchandise exports) of Fuel in 1999 to that in 2003?
Your answer should be compact. 0.4. What is the ratio of the Amount of exports(as % of merchandise exports) in Agricultural raw materials in 1999 to that in 2004?
Make the answer very short. 0.75. What is the ratio of the Amount of exports(as % of merchandise exports) of Food in 1999 to that in 2004?
Your answer should be compact. 1.28. What is the ratio of the Amount of exports(as % of merchandise exports) of Fuel in 1999 to that in 2004?
Make the answer very short. 0.35. What is the ratio of the Amount of exports(as % of merchandise exports) of Agricultural raw materials in 1999 to that in 2005?
Keep it short and to the point. 0.95. What is the ratio of the Amount of exports(as % of merchandise exports) in Food in 1999 to that in 2005?
Provide a short and direct response. 1.08. What is the ratio of the Amount of exports(as % of merchandise exports) in Fuel in 1999 to that in 2005?
Your response must be concise. 0.22. What is the ratio of the Amount of exports(as % of merchandise exports) in Agricultural raw materials in 2000 to that in 2001?
Give a very brief answer. 1.73. What is the ratio of the Amount of exports(as % of merchandise exports) of Food in 2000 to that in 2001?
Offer a terse response. 0.97. What is the ratio of the Amount of exports(as % of merchandise exports) of Fuel in 2000 to that in 2001?
Ensure brevity in your answer.  0.67. What is the ratio of the Amount of exports(as % of merchandise exports) of Agricultural raw materials in 2000 to that in 2002?
Your answer should be very brief. 2.01. What is the ratio of the Amount of exports(as % of merchandise exports) in Food in 2000 to that in 2002?
Give a very brief answer. 0.98. What is the ratio of the Amount of exports(as % of merchandise exports) of Fuel in 2000 to that in 2002?
Your answer should be very brief. 0.74. What is the ratio of the Amount of exports(as % of merchandise exports) in Agricultural raw materials in 2000 to that in 2003?
Your answer should be very brief. 1.86. What is the ratio of the Amount of exports(as % of merchandise exports) of Food in 2000 to that in 2003?
Keep it short and to the point. 0.98. What is the ratio of the Amount of exports(as % of merchandise exports) in Fuel in 2000 to that in 2003?
Your answer should be compact. 0.63. What is the ratio of the Amount of exports(as % of merchandise exports) in Agricultural raw materials in 2000 to that in 2004?
Provide a succinct answer. 1.55. What is the ratio of the Amount of exports(as % of merchandise exports) in Food in 2000 to that in 2004?
Provide a short and direct response. 1.04. What is the ratio of the Amount of exports(as % of merchandise exports) in Fuel in 2000 to that in 2004?
Your answer should be compact. 0.55. What is the ratio of the Amount of exports(as % of merchandise exports) of Agricultural raw materials in 2000 to that in 2005?
Offer a terse response. 1.97. What is the ratio of the Amount of exports(as % of merchandise exports) of Food in 2000 to that in 2005?
Your response must be concise. 0.87. What is the ratio of the Amount of exports(as % of merchandise exports) in Fuel in 2000 to that in 2005?
Give a very brief answer. 0.34. What is the ratio of the Amount of exports(as % of merchandise exports) in Agricultural raw materials in 2001 to that in 2002?
Offer a very short reply. 1.16. What is the ratio of the Amount of exports(as % of merchandise exports) in Food in 2001 to that in 2002?
Give a very brief answer. 1.01. What is the ratio of the Amount of exports(as % of merchandise exports) in Fuel in 2001 to that in 2002?
Your answer should be compact. 1.11. What is the ratio of the Amount of exports(as % of merchandise exports) in Agricultural raw materials in 2001 to that in 2003?
Offer a very short reply. 1.08. What is the ratio of the Amount of exports(as % of merchandise exports) of Food in 2001 to that in 2003?
Provide a succinct answer. 1.01. What is the ratio of the Amount of exports(as % of merchandise exports) of Fuel in 2001 to that in 2003?
Offer a terse response. 0.94. What is the ratio of the Amount of exports(as % of merchandise exports) in Agricultural raw materials in 2001 to that in 2004?
Ensure brevity in your answer.  0.9. What is the ratio of the Amount of exports(as % of merchandise exports) of Food in 2001 to that in 2004?
Ensure brevity in your answer.  1.07. What is the ratio of the Amount of exports(as % of merchandise exports) in Fuel in 2001 to that in 2004?
Provide a short and direct response. 0.83. What is the ratio of the Amount of exports(as % of merchandise exports) of Agricultural raw materials in 2001 to that in 2005?
Ensure brevity in your answer.  1.14. What is the ratio of the Amount of exports(as % of merchandise exports) of Food in 2001 to that in 2005?
Offer a terse response. 0.9. What is the ratio of the Amount of exports(as % of merchandise exports) of Fuel in 2001 to that in 2005?
Your response must be concise. 0.51. What is the ratio of the Amount of exports(as % of merchandise exports) in Agricultural raw materials in 2002 to that in 2003?
Offer a terse response. 0.93. What is the ratio of the Amount of exports(as % of merchandise exports) in Food in 2002 to that in 2003?
Offer a terse response. 1. What is the ratio of the Amount of exports(as % of merchandise exports) of Fuel in 2002 to that in 2003?
Make the answer very short. 0.85. What is the ratio of the Amount of exports(as % of merchandise exports) of Agricultural raw materials in 2002 to that in 2004?
Offer a very short reply. 0.77. What is the ratio of the Amount of exports(as % of merchandise exports) of Food in 2002 to that in 2004?
Your answer should be compact. 1.06. What is the ratio of the Amount of exports(as % of merchandise exports) in Fuel in 2002 to that in 2004?
Your response must be concise. 0.75. What is the ratio of the Amount of exports(as % of merchandise exports) of Agricultural raw materials in 2002 to that in 2005?
Give a very brief answer. 0.98. What is the ratio of the Amount of exports(as % of merchandise exports) in Food in 2002 to that in 2005?
Your answer should be very brief. 0.89. What is the ratio of the Amount of exports(as % of merchandise exports) of Fuel in 2002 to that in 2005?
Offer a very short reply. 0.46. What is the ratio of the Amount of exports(as % of merchandise exports) of Agricultural raw materials in 2003 to that in 2004?
Provide a short and direct response. 0.83. What is the ratio of the Amount of exports(as % of merchandise exports) in Food in 2003 to that in 2004?
Offer a very short reply. 1.06. What is the ratio of the Amount of exports(as % of merchandise exports) in Fuel in 2003 to that in 2004?
Provide a short and direct response. 0.88. What is the ratio of the Amount of exports(as % of merchandise exports) of Agricultural raw materials in 2003 to that in 2005?
Provide a short and direct response. 1.06. What is the ratio of the Amount of exports(as % of merchandise exports) in Food in 2003 to that in 2005?
Your answer should be very brief. 0.89. What is the ratio of the Amount of exports(as % of merchandise exports) in Fuel in 2003 to that in 2005?
Provide a short and direct response. 0.54. What is the ratio of the Amount of exports(as % of merchandise exports) in Agricultural raw materials in 2004 to that in 2005?
Give a very brief answer. 1.28. What is the ratio of the Amount of exports(as % of merchandise exports) of Food in 2004 to that in 2005?
Your answer should be very brief. 0.84. What is the ratio of the Amount of exports(as % of merchandise exports) in Fuel in 2004 to that in 2005?
Offer a terse response. 0.62. What is the difference between the highest and the second highest Amount of exports(as % of merchandise exports) in Agricultural raw materials?
Give a very brief answer. 0.22. What is the difference between the highest and the second highest Amount of exports(as % of merchandise exports) of Food?
Provide a succinct answer. 0.49. What is the difference between the highest and the second highest Amount of exports(as % of merchandise exports) in Fuel?
Make the answer very short. 1.6. What is the difference between the highest and the lowest Amount of exports(as % of merchandise exports) in Agricultural raw materials?
Your answer should be very brief. 1.53. What is the difference between the highest and the lowest Amount of exports(as % of merchandise exports) in Food?
Offer a terse response. 3.45. What is the difference between the highest and the lowest Amount of exports(as % of merchandise exports) of Fuel?
Your answer should be compact. 3.87. 